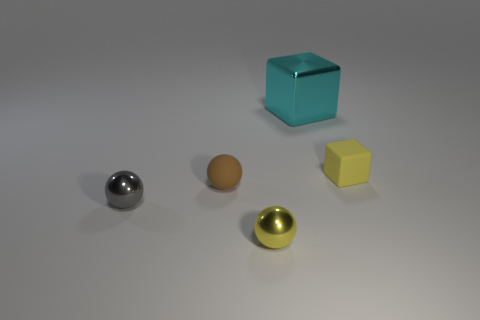Are there any yellow objects made of the same material as the small gray thing?
Provide a succinct answer. Yes. The tiny yellow thing to the right of the metallic ball that is to the right of the brown rubber ball is made of what material?
Make the answer very short. Rubber. There is a small object that is behind the small gray shiny ball and on the left side of the big cyan thing; what material is it?
Ensure brevity in your answer.  Rubber. Are there an equal number of cyan metal cubes that are behind the big cyan metal thing and cyan blocks?
Your answer should be very brief. No. How many tiny brown rubber things have the same shape as the yellow shiny object?
Ensure brevity in your answer.  1. How big is the ball that is to the right of the rubber thing that is to the left of the small metal ball in front of the gray metallic sphere?
Ensure brevity in your answer.  Small. Is the yellow object on the left side of the cyan metallic cube made of the same material as the gray thing?
Your answer should be compact. Yes. Are there an equal number of matte cubes to the right of the small rubber block and gray shiny spheres that are behind the tiny yellow sphere?
Your response must be concise. No. Is there any other thing that has the same size as the shiny block?
Your answer should be compact. No. What is the material of the gray thing that is the same shape as the tiny yellow shiny object?
Offer a terse response. Metal. 